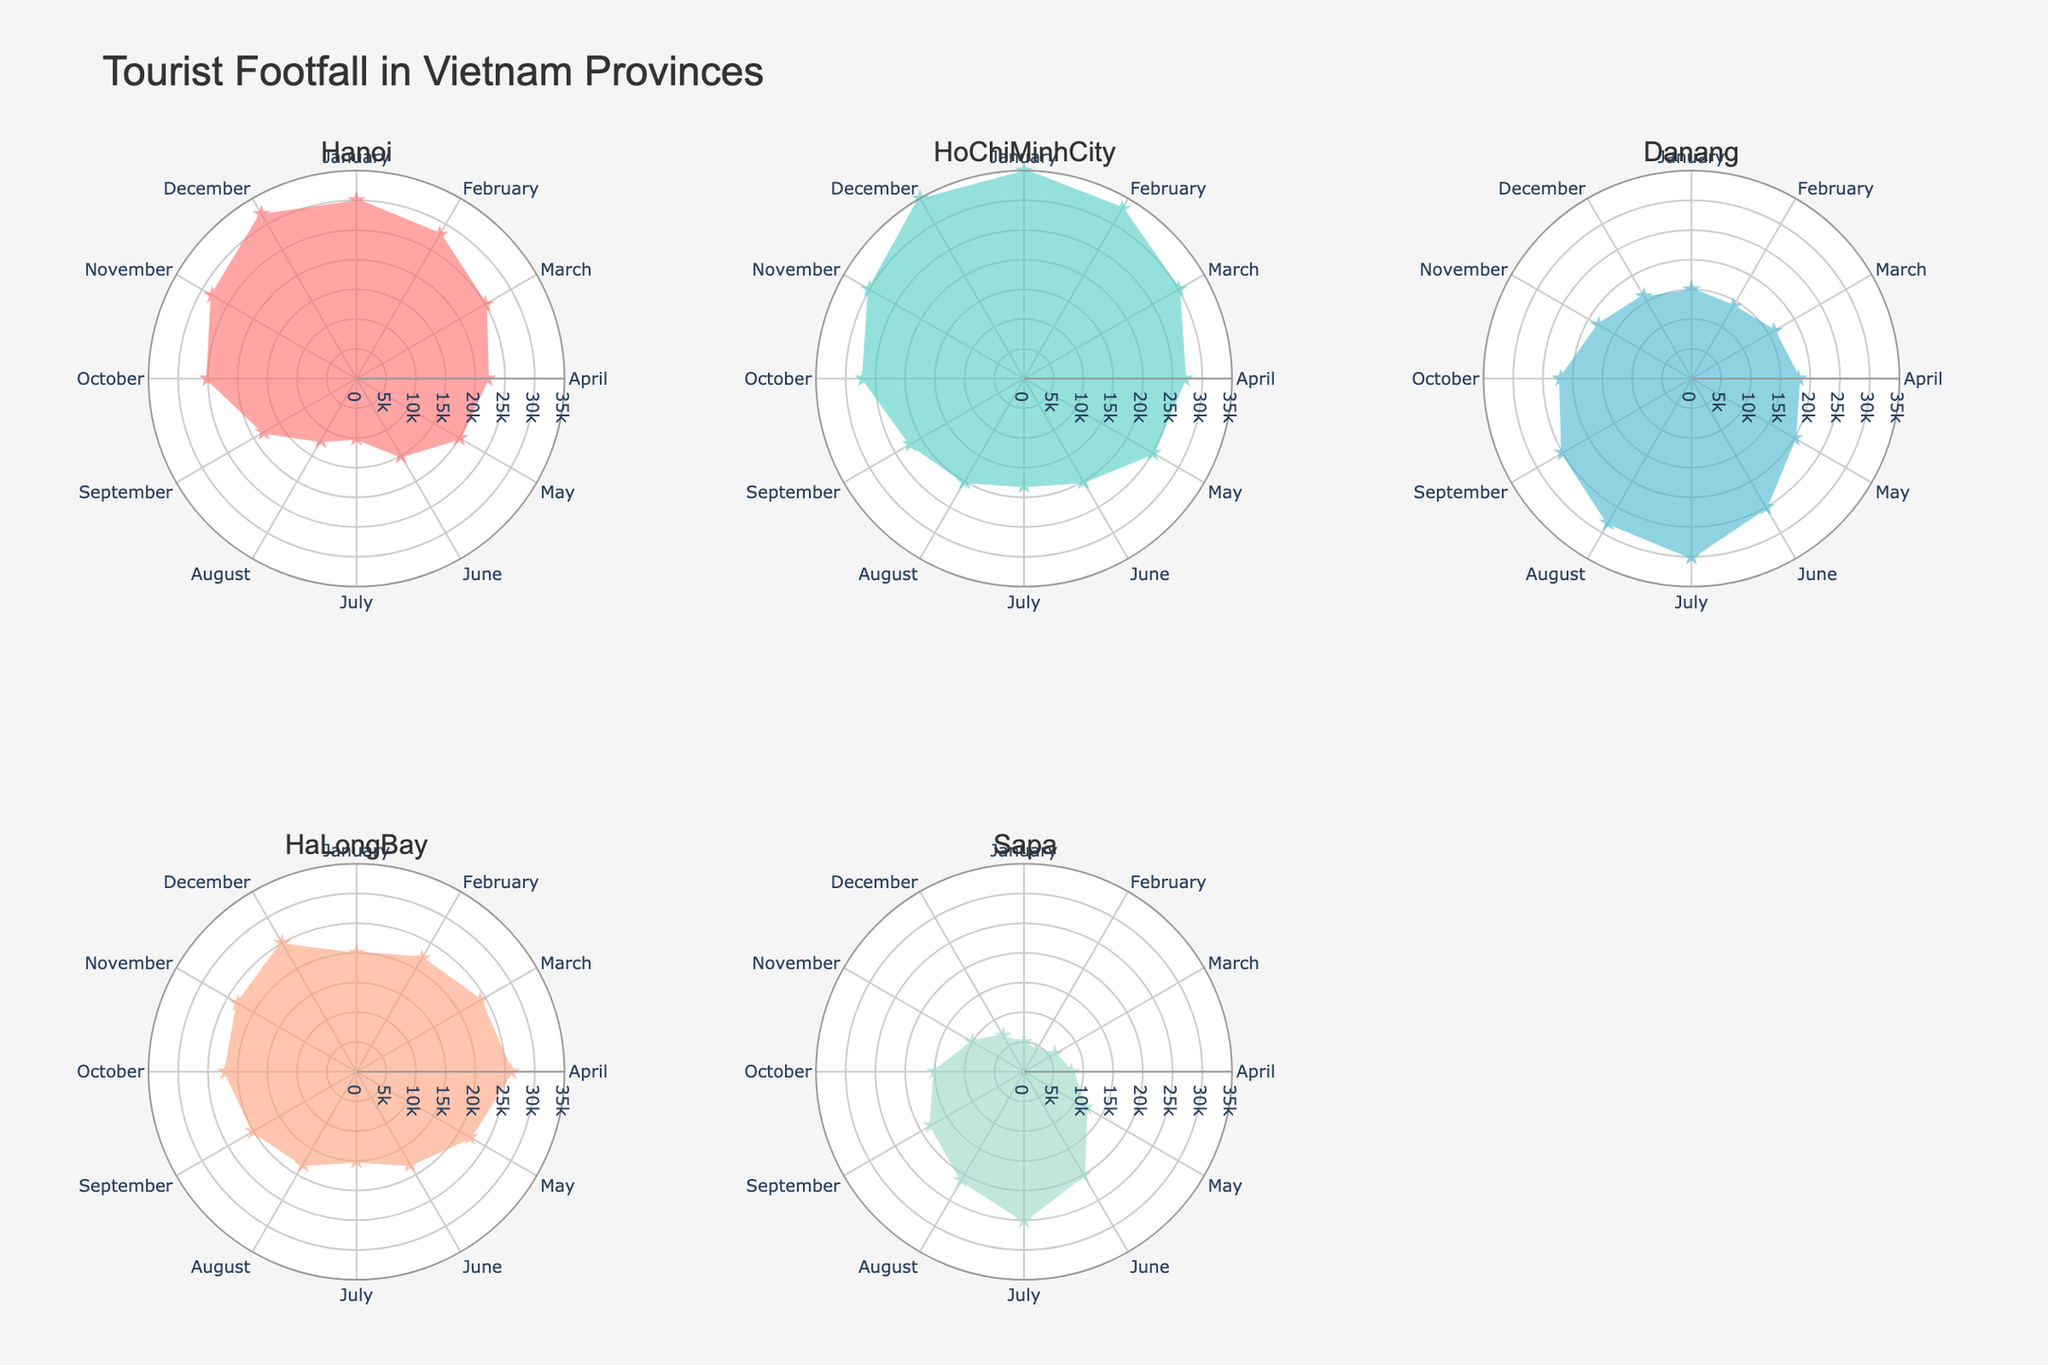How does the tourist footfall in Hanoi compare between January and July? We look at the polar chart for Hanoi and compare the lengths of the radial lines for January and July. January has approximately 30000 tourists, whereas July has 10000 tourists.
Answer: January has significantly higher footfall than July Which month has the highest tourist footfall in HoChiMinhCity? By observing the radial lines in the polar chart for HoChiMinhCity, December has the longest line, indicating the highest tourist footfall.
Answer: December What is the average tourist footfall in Danang during the summer months (June, July, August)? Look for the data points for June (25000), July (30000), and August (28000) in the Danang chart. Summing them gives 25000 + 30000 + 28000 = 83000. The average is 83000/3.
Answer: 27667 Is there any month in HaLongBay that has a tourist footfall equal to a summer month in Sapa (June, July, August)? Look at the radial lines for HaLongBay and compare to June (20000), July (25000), and August (21000) in the Sapa chart. November in HaLongBay has 23000 tourists which is within the range of Sapa's summer months.
Answer: Yes, November What pattern can be observed in the tourist footfall in Sapa from January to December? Examine the polar chart for Sapa. The tourist footfall starts low in January, increases steadily through July, reaching a peak, and then decreases towards December.
Answer: Increase to peak in July, then decrease 